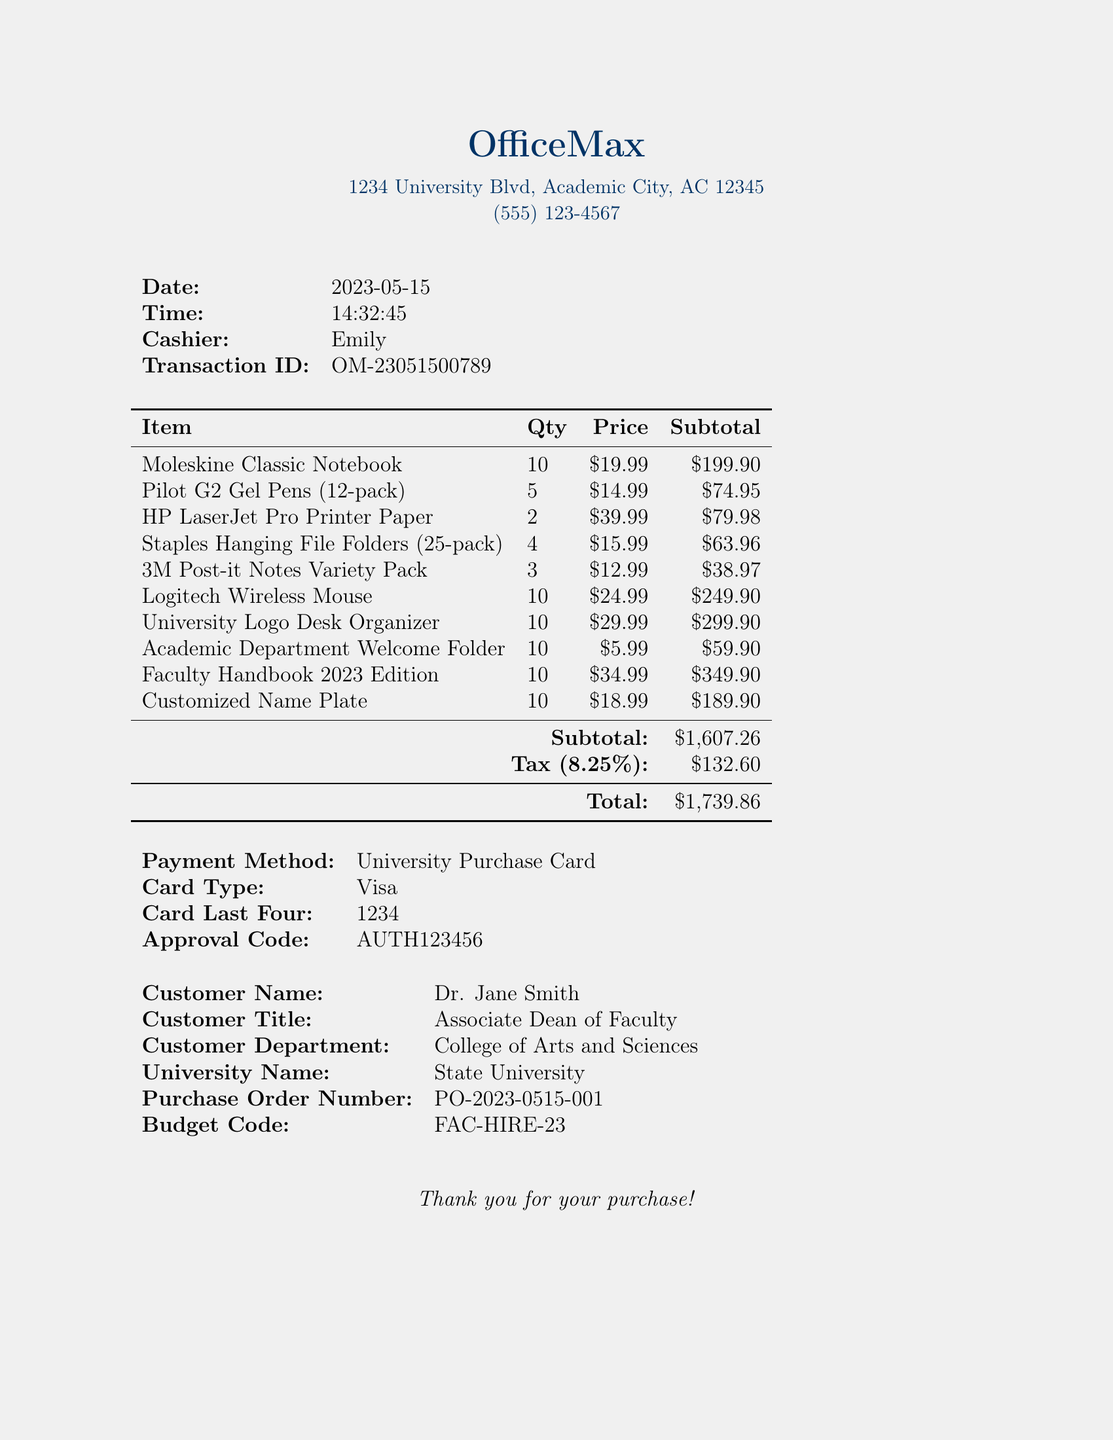What is the store's name? The store's name is mentioned at the top of the document.
Answer: OfficeMax Who was the cashier during this transaction? The cashier's name is listed in the transaction details.
Answer: Emily What is the date of the transaction? The date is specified in the transaction details.
Answer: 2023-05-15 How many Moleskine Classic Notebooks were purchased? The quantity of Moleskine Classic Notebooks is provided in the itemized list.
Answer: 10 What is the total amount spent on the purchase? The total amount is presented at the bottom of the document.
Answer: $1,739.86 What is the subtotal before tax? The subtotal is calculated before adding tax and is found in the itemized list.
Answer: $1,607.26 What payment method was used? The payment method is specified in the transaction details section of the document.
Answer: University Purchase Card Which item had the highest subtotal? The highest subtotal can be determined by comparing the subtotals of each item listed.
Answer: Faculty Handbook 2023 Edition What is the budget code for this purchase? The budget code is provided in the transaction details.
Answer: FAC-HIRE-23 